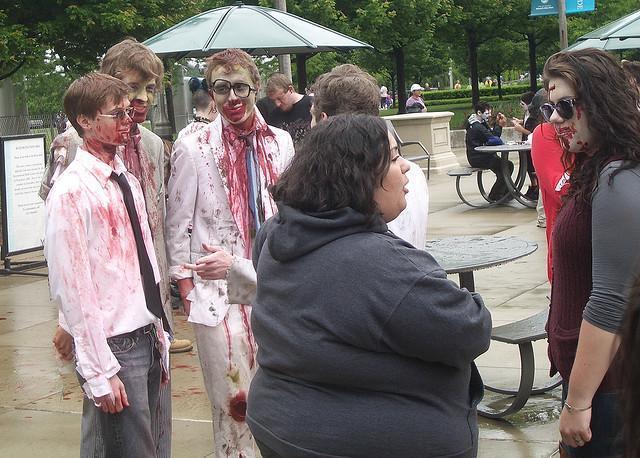How many dining tables are visible?
Give a very brief answer. 2. How many people can you see?
Give a very brief answer. 10. How many motors are on the boat on the left?
Give a very brief answer. 0. 